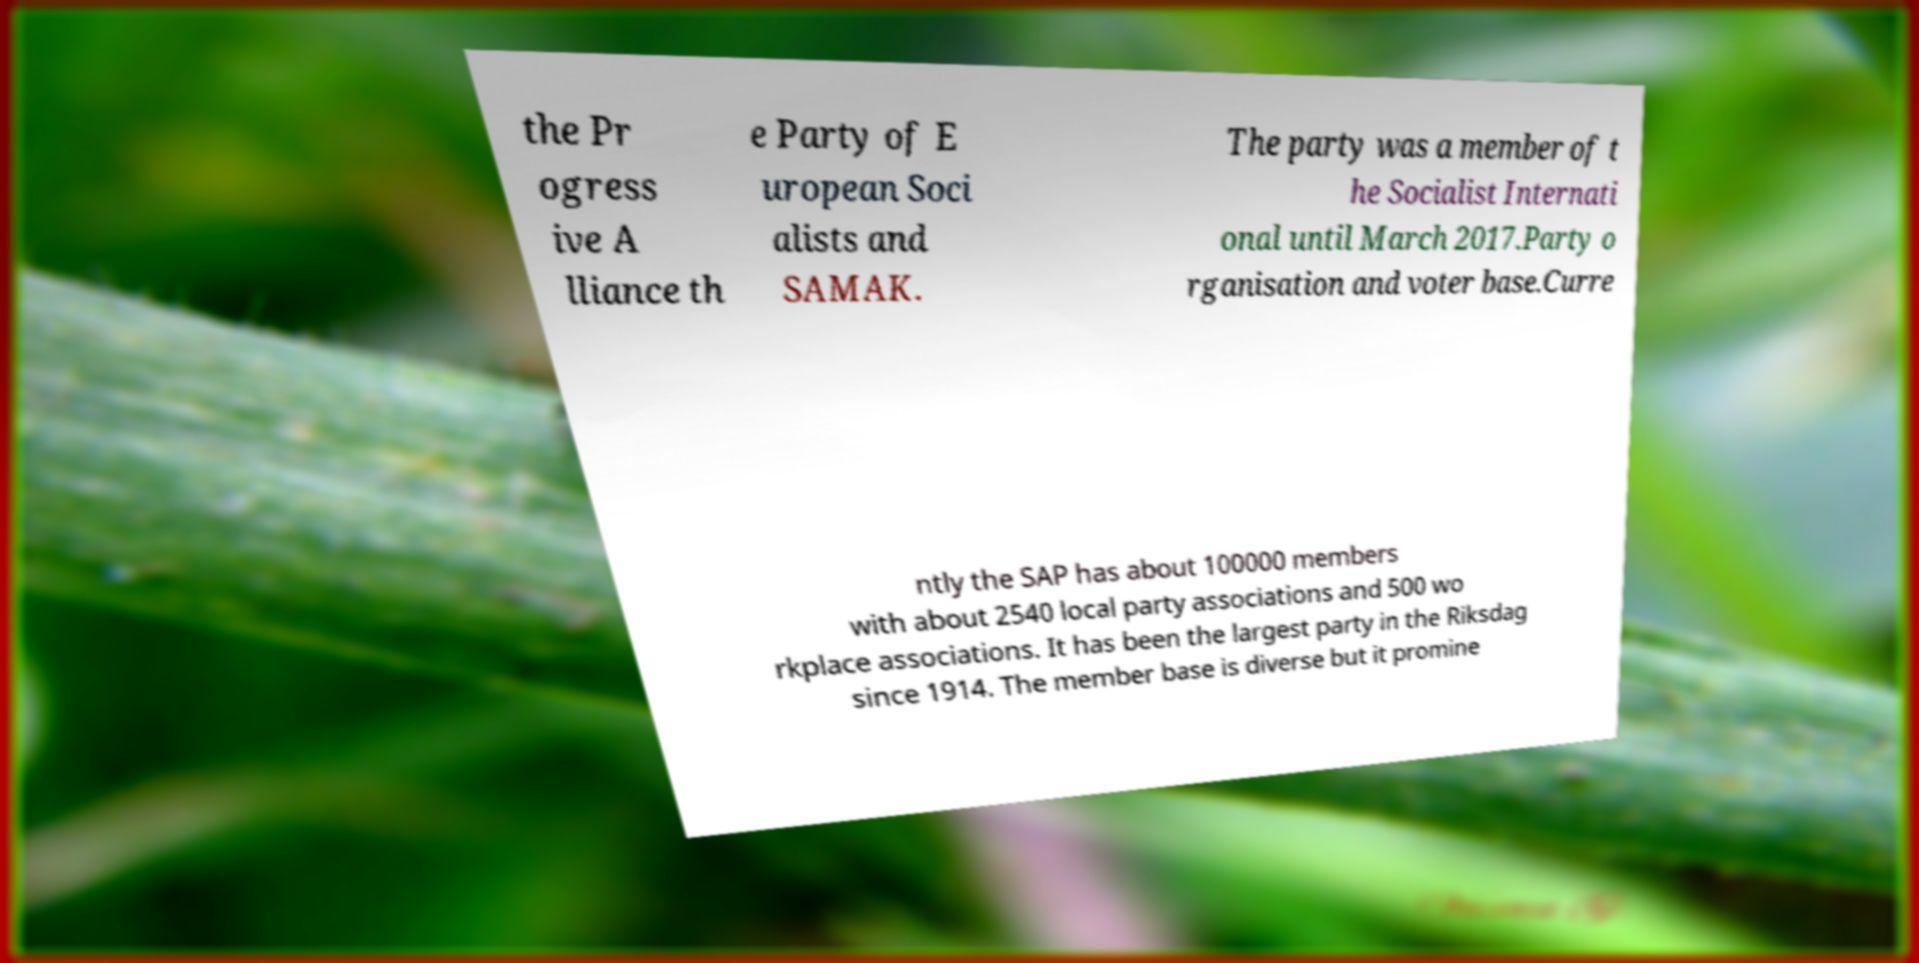Could you extract and type out the text from this image? the Pr ogress ive A lliance th e Party of E uropean Soci alists and SAMAK. The party was a member of t he Socialist Internati onal until March 2017.Party o rganisation and voter base.Curre ntly the SAP has about 100000 members with about 2540 local party associations and 500 wo rkplace associations. It has been the largest party in the Riksdag since 1914. The member base is diverse but it promine 